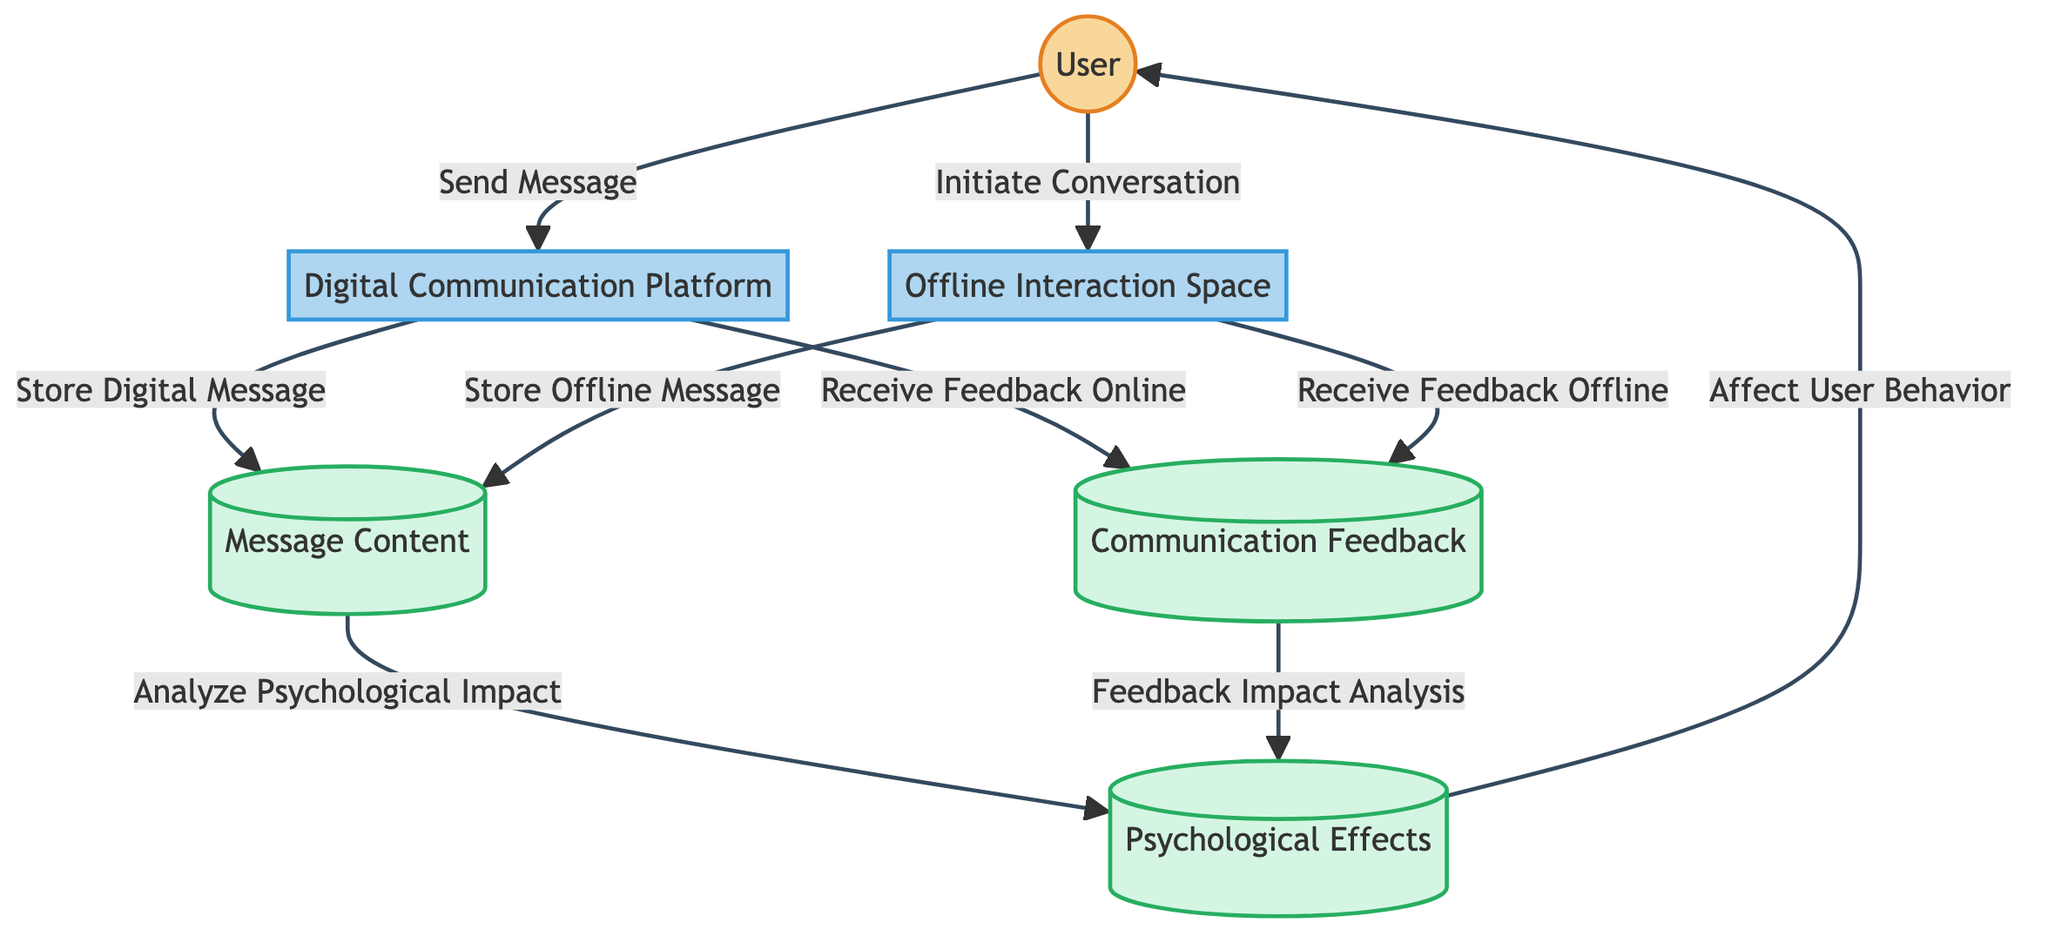What is the external entity involved in the diagram? The external entity in the diagram is the "User," who engages in communication.
Answer: User How many processes are depicted in the diagram? There are two processes shown: "Digital Communication Platform" and "Offline Interaction Space."
Answer: 2 What data store receives feedback from the Digital Communication Platform? The data store that receives feedback is "Communication Feedback."
Answer: Communication Feedback What is the action taken when the User engages in face-to-face communication? The action taken is "Initiate Conversation."
Answer: Initiate Conversation Which data store is analyzed for psychological impact in the communication process? The data store analyzed is "Message Content."
Answer: Message Content What is stored after the User sends a message via the Digital Communication Platform? After the message is sent, the "Message Content" is stored.
Answer: Message Content What flows from "Communication Feedback" to "Psychological Effects"? The flow from "Communication Feedback" to "Psychological Effects" is "Feedback Impact Analysis."
Answer: Feedback Impact Analysis Which process involves immediate feedback reception? The process that involves immediate feedback reception is the "Offline Interaction Space."
Answer: Offline Interaction Space How does the "Psychological Effects" node influence the User? It influences the User's future behavior and interactions.
Answer: Affect User Behavior 